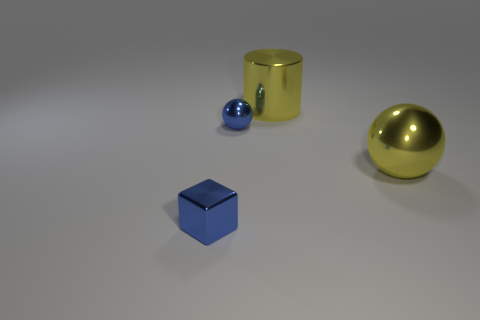There is a large yellow metal object that is on the right side of the large yellow metal object behind the big yellow metal sphere; what shape is it?
Your answer should be very brief. Sphere. What size is the metallic block?
Offer a very short reply. Small. How many shiny objects are both left of the large yellow metal cylinder and in front of the small blue sphere?
Provide a short and direct response. 1. What number of other things are there of the same size as the blue shiny sphere?
Give a very brief answer. 1. Are there an equal number of blue things in front of the large yellow ball and tiny purple blocks?
Ensure brevity in your answer.  No. There is a tiny metal object on the right side of the small block; is its color the same as the big metallic object right of the big cylinder?
Keep it short and to the point. No. The thing that is both in front of the cylinder and right of the small blue shiny ball is made of what material?
Provide a succinct answer. Metal. The small block has what color?
Your answer should be compact. Blue. Is the number of blue shiny cubes on the right side of the cylinder the same as the number of blue things in front of the small blue block?
Make the answer very short. Yes. What material is the tiny cube?
Offer a terse response. Metal. 